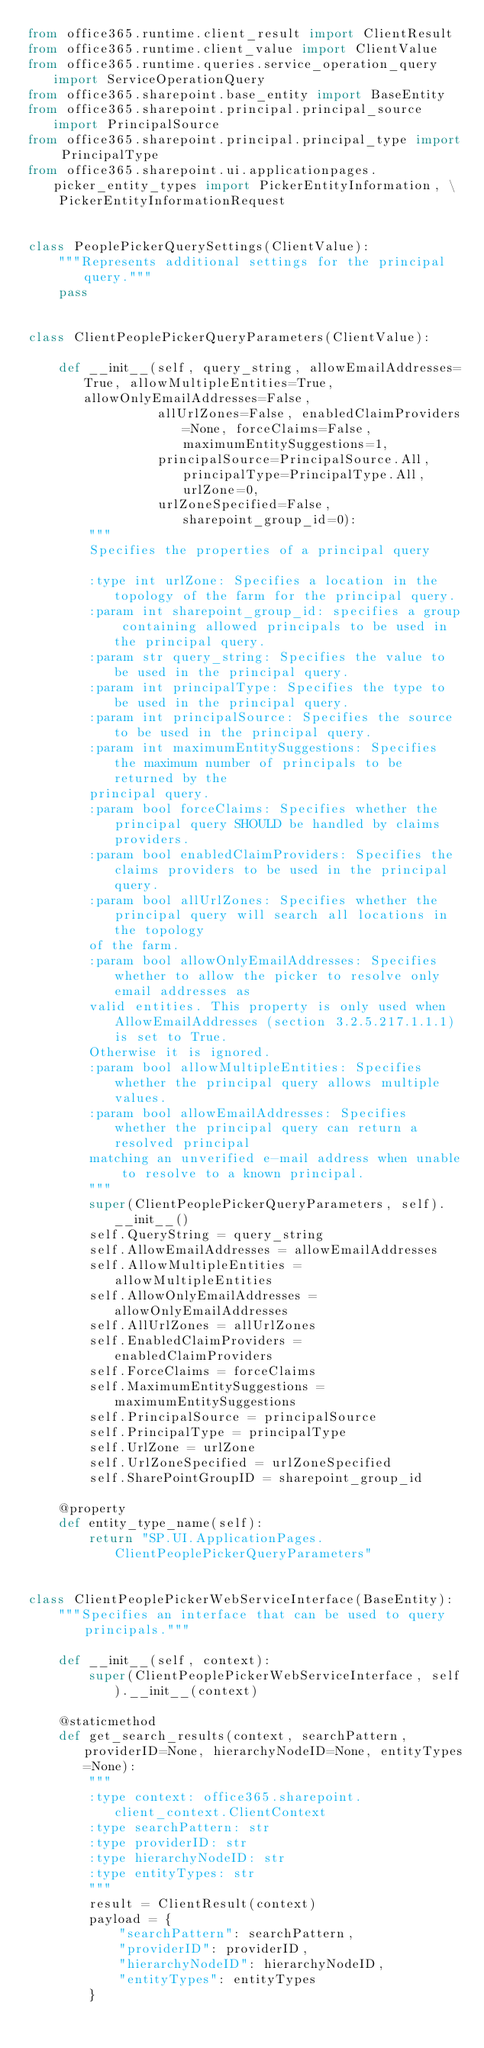<code> <loc_0><loc_0><loc_500><loc_500><_Python_>from office365.runtime.client_result import ClientResult
from office365.runtime.client_value import ClientValue
from office365.runtime.queries.service_operation_query import ServiceOperationQuery
from office365.sharepoint.base_entity import BaseEntity
from office365.sharepoint.principal.principal_source import PrincipalSource
from office365.sharepoint.principal.principal_type import PrincipalType
from office365.sharepoint.ui.applicationpages.picker_entity_types import PickerEntityInformation, \
    PickerEntityInformationRequest


class PeoplePickerQuerySettings(ClientValue):
    """Represents additional settings for the principal query."""
    pass


class ClientPeoplePickerQueryParameters(ClientValue):

    def __init__(self, query_string, allowEmailAddresses=True, allowMultipleEntities=True, allowOnlyEmailAddresses=False,
                 allUrlZones=False, enabledClaimProviders=None, forceClaims=False, maximumEntitySuggestions=1,
                 principalSource=PrincipalSource.All, principalType=PrincipalType.All, urlZone=0,
                 urlZoneSpecified=False, sharepoint_group_id=0):
        """
        Specifies the properties of a principal query

        :type int urlZone: Specifies a location in the topology of the farm for the principal query.
        :param int sharepoint_group_id: specifies a group containing allowed principals to be used in the principal query.
        :param str query_string: Specifies the value to be used in the principal query.
        :param int principalType: Specifies the type to be used in the principal query.
        :param int principalSource: Specifies the source to be used in the principal query.
        :param int maximumEntitySuggestions: Specifies the maximum number of principals to be returned by the
        principal query.
        :param bool forceClaims: Specifies whether the principal query SHOULD be handled by claims providers.
        :param bool enabledClaimProviders: Specifies the claims providers to be used in the principal query.
        :param bool allUrlZones: Specifies whether the principal query will search all locations in the topology
        of the farm.
        :param bool allowOnlyEmailAddresses: Specifies whether to allow the picker to resolve only email addresses as
        valid entities. This property is only used when AllowEmailAddresses (section 3.2.5.217.1.1.1) is set to True.
        Otherwise it is ignored.
        :param bool allowMultipleEntities: Specifies whether the principal query allows multiple values.
        :param bool allowEmailAddresses: Specifies whether the principal query can return a resolved principal
        matching an unverified e-mail address when unable to resolve to a known principal.
        """
        super(ClientPeoplePickerQueryParameters, self).__init__()
        self.QueryString = query_string
        self.AllowEmailAddresses = allowEmailAddresses
        self.AllowMultipleEntities = allowMultipleEntities
        self.AllowOnlyEmailAddresses = allowOnlyEmailAddresses
        self.AllUrlZones = allUrlZones
        self.EnabledClaimProviders = enabledClaimProviders
        self.ForceClaims = forceClaims
        self.MaximumEntitySuggestions = maximumEntitySuggestions
        self.PrincipalSource = principalSource
        self.PrincipalType = principalType
        self.UrlZone = urlZone
        self.UrlZoneSpecified = urlZoneSpecified
        self.SharePointGroupID = sharepoint_group_id

    @property
    def entity_type_name(self):
        return "SP.UI.ApplicationPages.ClientPeoplePickerQueryParameters"


class ClientPeoplePickerWebServiceInterface(BaseEntity):
    """Specifies an interface that can be used to query principals."""

    def __init__(self, context):
        super(ClientPeoplePickerWebServiceInterface, self).__init__(context)

    @staticmethod
    def get_search_results(context, searchPattern, providerID=None, hierarchyNodeID=None, entityTypes=None):
        """
        :type context: office365.sharepoint.client_context.ClientContext
        :type searchPattern: str
        :type providerID: str
        :type hierarchyNodeID: str
        :type entityTypes: str
        """
        result = ClientResult(context)
        payload = {
            "searchPattern": searchPattern,
            "providerID": providerID,
            "hierarchyNodeID": hierarchyNodeID,
            "entityTypes": entityTypes
        }</code> 